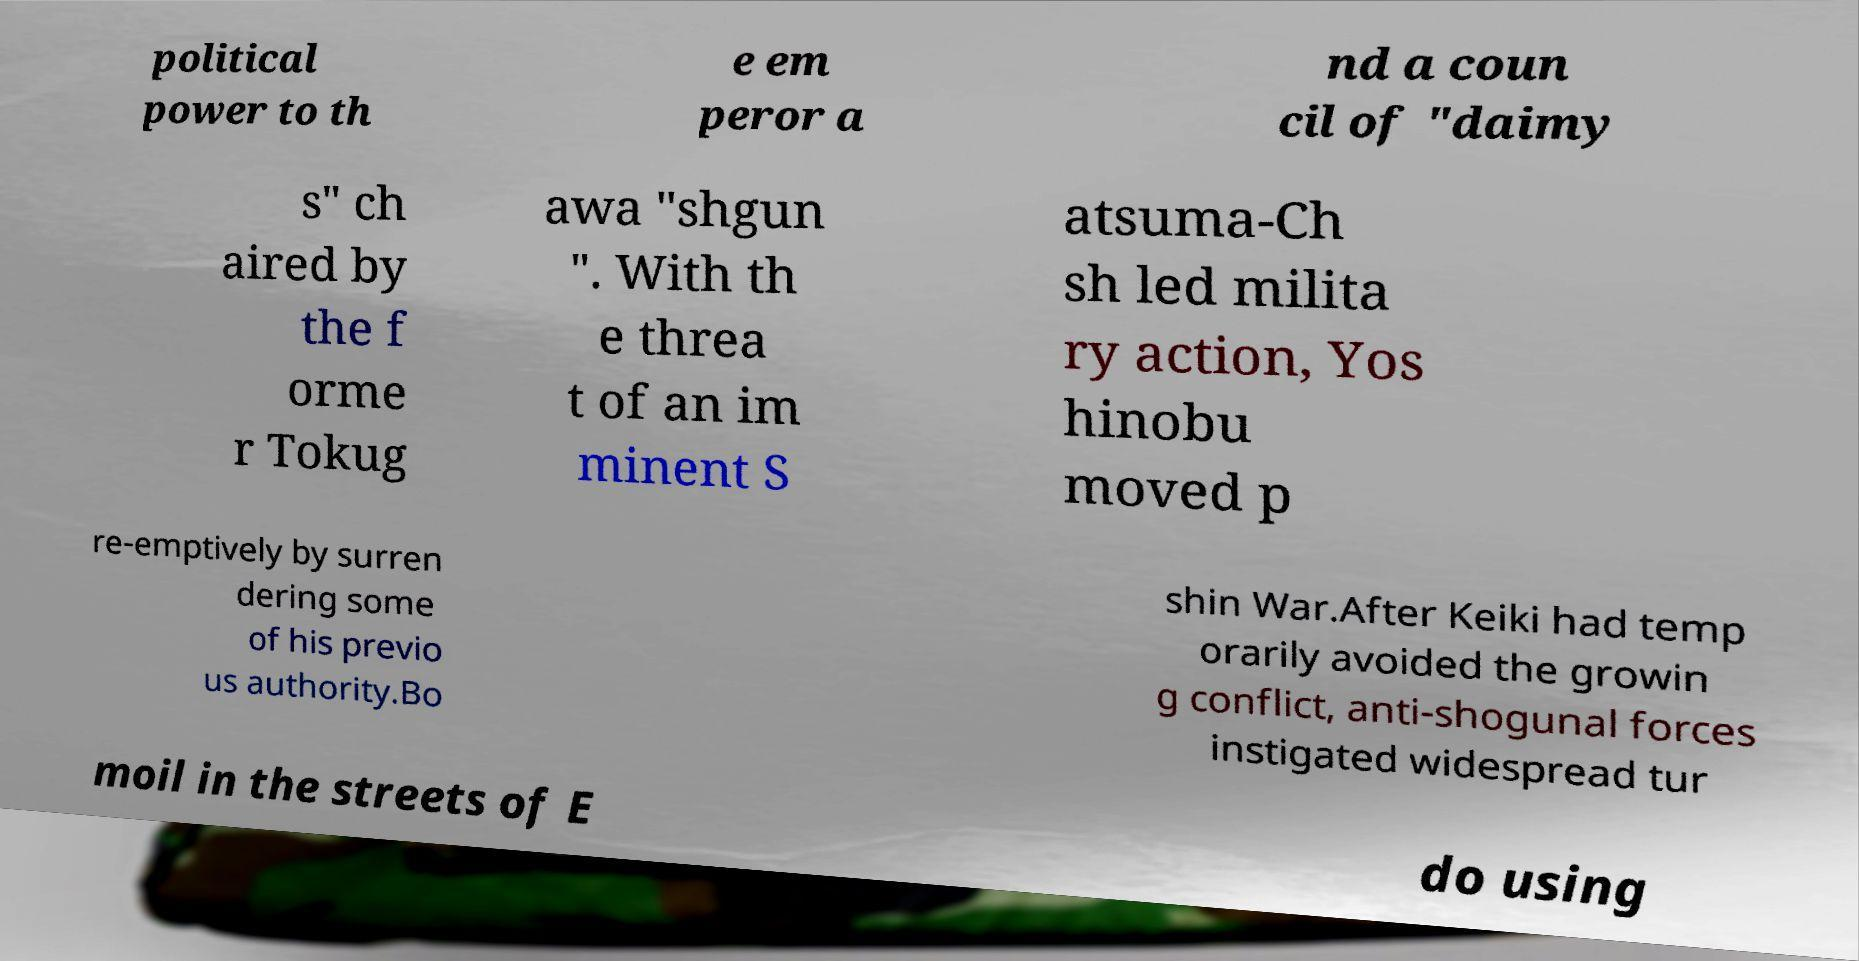Please read and relay the text visible in this image. What does it say? political power to th e em peror a nd a coun cil of "daimy s" ch aired by the f orme r Tokug awa "shgun ". With th e threa t of an im minent S atsuma-Ch sh led milita ry action, Yos hinobu moved p re-emptively by surren dering some of his previo us authority.Bo shin War.After Keiki had temp orarily avoided the growin g conflict, anti-shogunal forces instigated widespread tur moil in the streets of E do using 